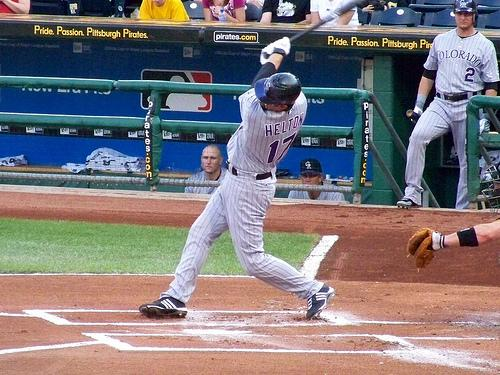Identify the different types of shoes and gloves present in the image. There is a black shoe with white stripes and a baseball player wearing a black shoe. White gloves are on hands, and there is a hand with a baseball mitt as well as a catcher wearing a brown glove. Describe any interesting or prominent signs or markers in the image. There are yellow and black signs in the stadium, possibly indicating advertisements or team logos, located in different sections of the image. Analyze the image to find any anomalies or unusual elements. One unusual element is the baseball bat appearing in the back of a player's head, which might be due to overlapping objects during image annotation. Tell me something about the uniforms of the baseball players in the image.  The baseball players are wearing blue and gray uniforms with numbers such as 17 and 2 on them. The uniforms also have vertical stripes on the pants. Assess the sentiment or mood of the image based on the objects and subjects present. The image conveys an exciting and competitive mood because of the baseball game, players in action, and fans watching attentively. Provide information about the baseball bat in the image. The baseball bat is wooden, black in color, and is being held by the hands of a baseball player swinging it. Examine the image and describe the setting of the baseball game. The baseball game is set in a stadium, with a green metal dugout railing, a sandy playing ground, green grass sections, and fans watching the game. Provide three key elements of the image that help us contextualize the scene. Green grass, sandy ground, and players wearing blue and gray uniforms help contextualize the scene as a baseball game in a stadium. What sport is being played in the image? Mention the key objects and details related to it. The sport being played is baseball, with key objects like baseball players wearing uniforms, helmets and gloves, a baseball bat, a baseball mitt, and the playing ground with green grass and sandy areas. Identify the player who is actively engaged in playing and describe their posture and action. A baseball player in a twisted body position is actively engaged, swinging a wooden bat and wearing a black helmet, with their heel lifted off white chalk. Just behind the player watching from the dugout, there is a large scoreboard showing the current score of the game. This instruction is misleading because there is no mention of a scoreboard in any of the captions. It introduces an object that is unrelated to the given details. What is the color of the grass in the stadium? green Find the ice cream vendor walking through the stadium while the baseball player with twisted body is in motion. This instruction is misleading because there is no mention of an ice cream vendor in any of the captions. The combined elements of an ice cream vendor and a baseball player in motion create a specific detail not found in the given information. Is the baseball bat made of wood or metal? wood What color is the helmet worn by the baseball player? black Can you find a basketball player jumping to make a slam dunk in this image? This instruction is misleading because the image contains information about a baseball game, not a basketball game, and there is no mention of a basketball player or any action related to basketball. Describe the appearance of the baseball player's uniform. blue and gray uniform What text can be read from the image? no readable text Name an object in the image that is not directly related to playing baseball. green railing covered with soft material Does the baseball player have their heel lifted off the chalk? yes Describe the overall sentiment conveyed by the image. competitive and focused Do you see the hot air balloon soaring in the sky above the baseball game? This instruction is misleading because none of the given captions mention a hot air balloon or anything in the sky. The entire scene seems to be focused on the baseball game happening on the ground. What kind of glove is on the extended arm? mitt over the hand Are there any signs visible in the image? If so, describe their colors. yes, yellow and black signs Can you spot the golden retriever sitting next to the man wearing a blue cap, watching the game intently? This instruction is misleading because none of the captions mention a golden retriever or any animals. It suggests the presence of a specific breed of dog, which wasn't mentioned in any part of the image information. Is there a catcher visible in the image? yes, wearing a brown glove What type of ground is visible in the image? sandy Identify the main subject of the image. a baseball player Notice the elephant standing in the far corner of the baseball field, just past the green grass section. This instruction is misleading because there is no mention of an elephant in any of the captions. Additionally, it's highly unlikely that there would be an elephant in a baseball stadium. Count the number of fans shown watching the game. not visible Is the baseball player wearing a glove on their hand? yes, a white glove Point out any inconsistency or anomaly found in the image. no anomalies detected What is the feeling or emotion conveyed by the baseball player's body language? intense and concentrated What type of shoe is the baseball player wearing? black shoe with white stripes How many uniform numbers can be seen in the image, and what are they? 2, numbers 17 and 2 Evaluate the image quality based on the clarity of its subjects. good clarity 